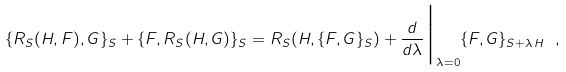Convert formula to latex. <formula><loc_0><loc_0><loc_500><loc_500>\{ R _ { S } ( H , F ) , G \} _ { S } + \{ F , R _ { S } ( H , G ) \} _ { S } = R _ { S } ( H , \{ F , G \} _ { S } ) + \frac { d } { d \lambda } \Big | _ { \lambda = 0 } \{ F , G \} _ { S + \lambda \, H } \ ,</formula> 